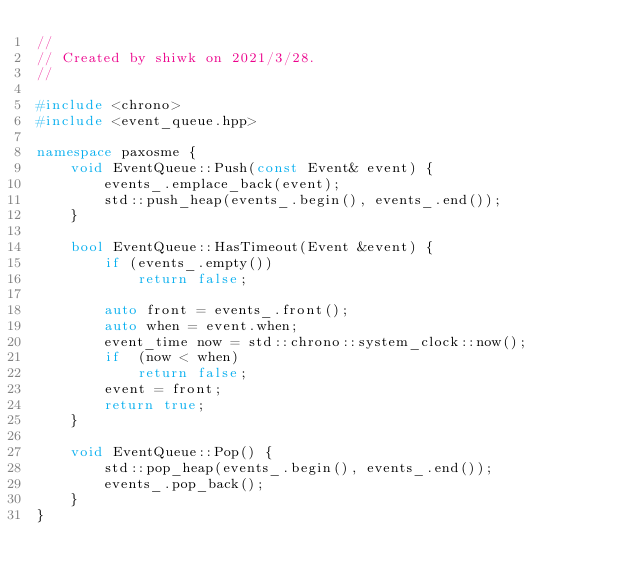<code> <loc_0><loc_0><loc_500><loc_500><_C++_>//
// Created by shiwk on 2021/3/28.
//

#include <chrono>
#include <event_queue.hpp>

namespace paxosme {
    void EventQueue::Push(const Event& event) {
        events_.emplace_back(event);
        std::push_heap(events_.begin(), events_.end());
    }

    bool EventQueue::HasTimeout(Event &event) {
        if (events_.empty())
            return false;

        auto front = events_.front();
        auto when = event.when;
        event_time now = std::chrono::system_clock::now();
        if  (now < when)
            return false;
        event = front;
        return true;
    }

    void EventQueue::Pop() {
        std::pop_heap(events_.begin(), events_.end());
        events_.pop_back();
    }
}</code> 